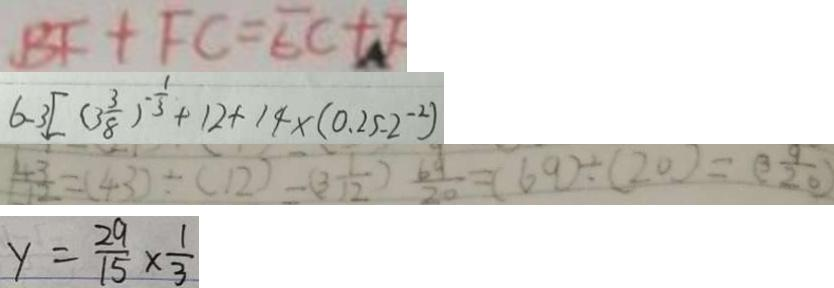<formula> <loc_0><loc_0><loc_500><loc_500>B F + F C = E C + F 
 6 - 3 [ ( 3 \frac { 3 } { 8 } ) ^ { - \frac { 1 } { 3 } } + 1 2 + 1 4 \times ( 0 . 2 5 - 2 ^ { - 2 } ) 
 \frac { 4 3 } { 1 2 } = ( 4 3 ) \div ( 1 2 ) = ( 3 \frac { 1 } { 1 2 } ) \frac { 6 9 } { 2 0 } = ( 6 9 ) \div ( 2 0 ) = ( 3 \frac { 9 } { 2 0 } ) 
 y = \frac { 2 9 } { 1 5 } \times \frac { 1 } { 3 }</formula> 